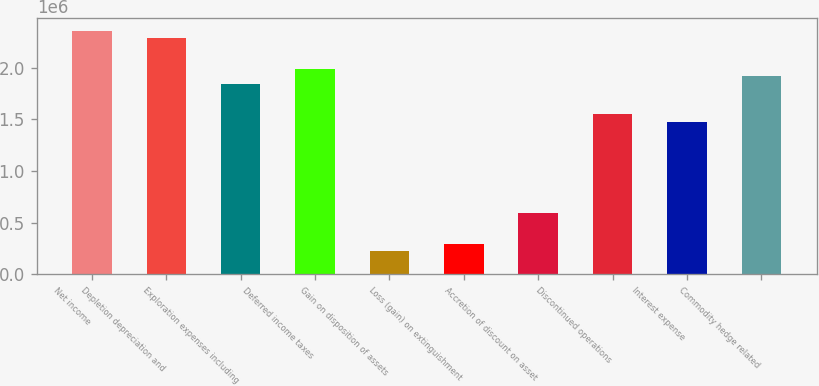<chart> <loc_0><loc_0><loc_500><loc_500><bar_chart><fcel>Net income<fcel>Depletion depreciation and<fcel>Exploration expenses including<fcel>Deferred income taxes<fcel>Gain on disposition of assets<fcel>Loss (gain) on extinguishment<fcel>Accretion of discount on asset<fcel>Discontinued operations<fcel>Interest expense<fcel>Commodity hedge related<nl><fcel>2.36102e+06<fcel>2.28725e+06<fcel>1.84464e+06<fcel>1.99217e+06<fcel>221730<fcel>295498<fcel>590572<fcel>1.54956e+06<fcel>1.47579e+06<fcel>1.9184e+06<nl></chart> 